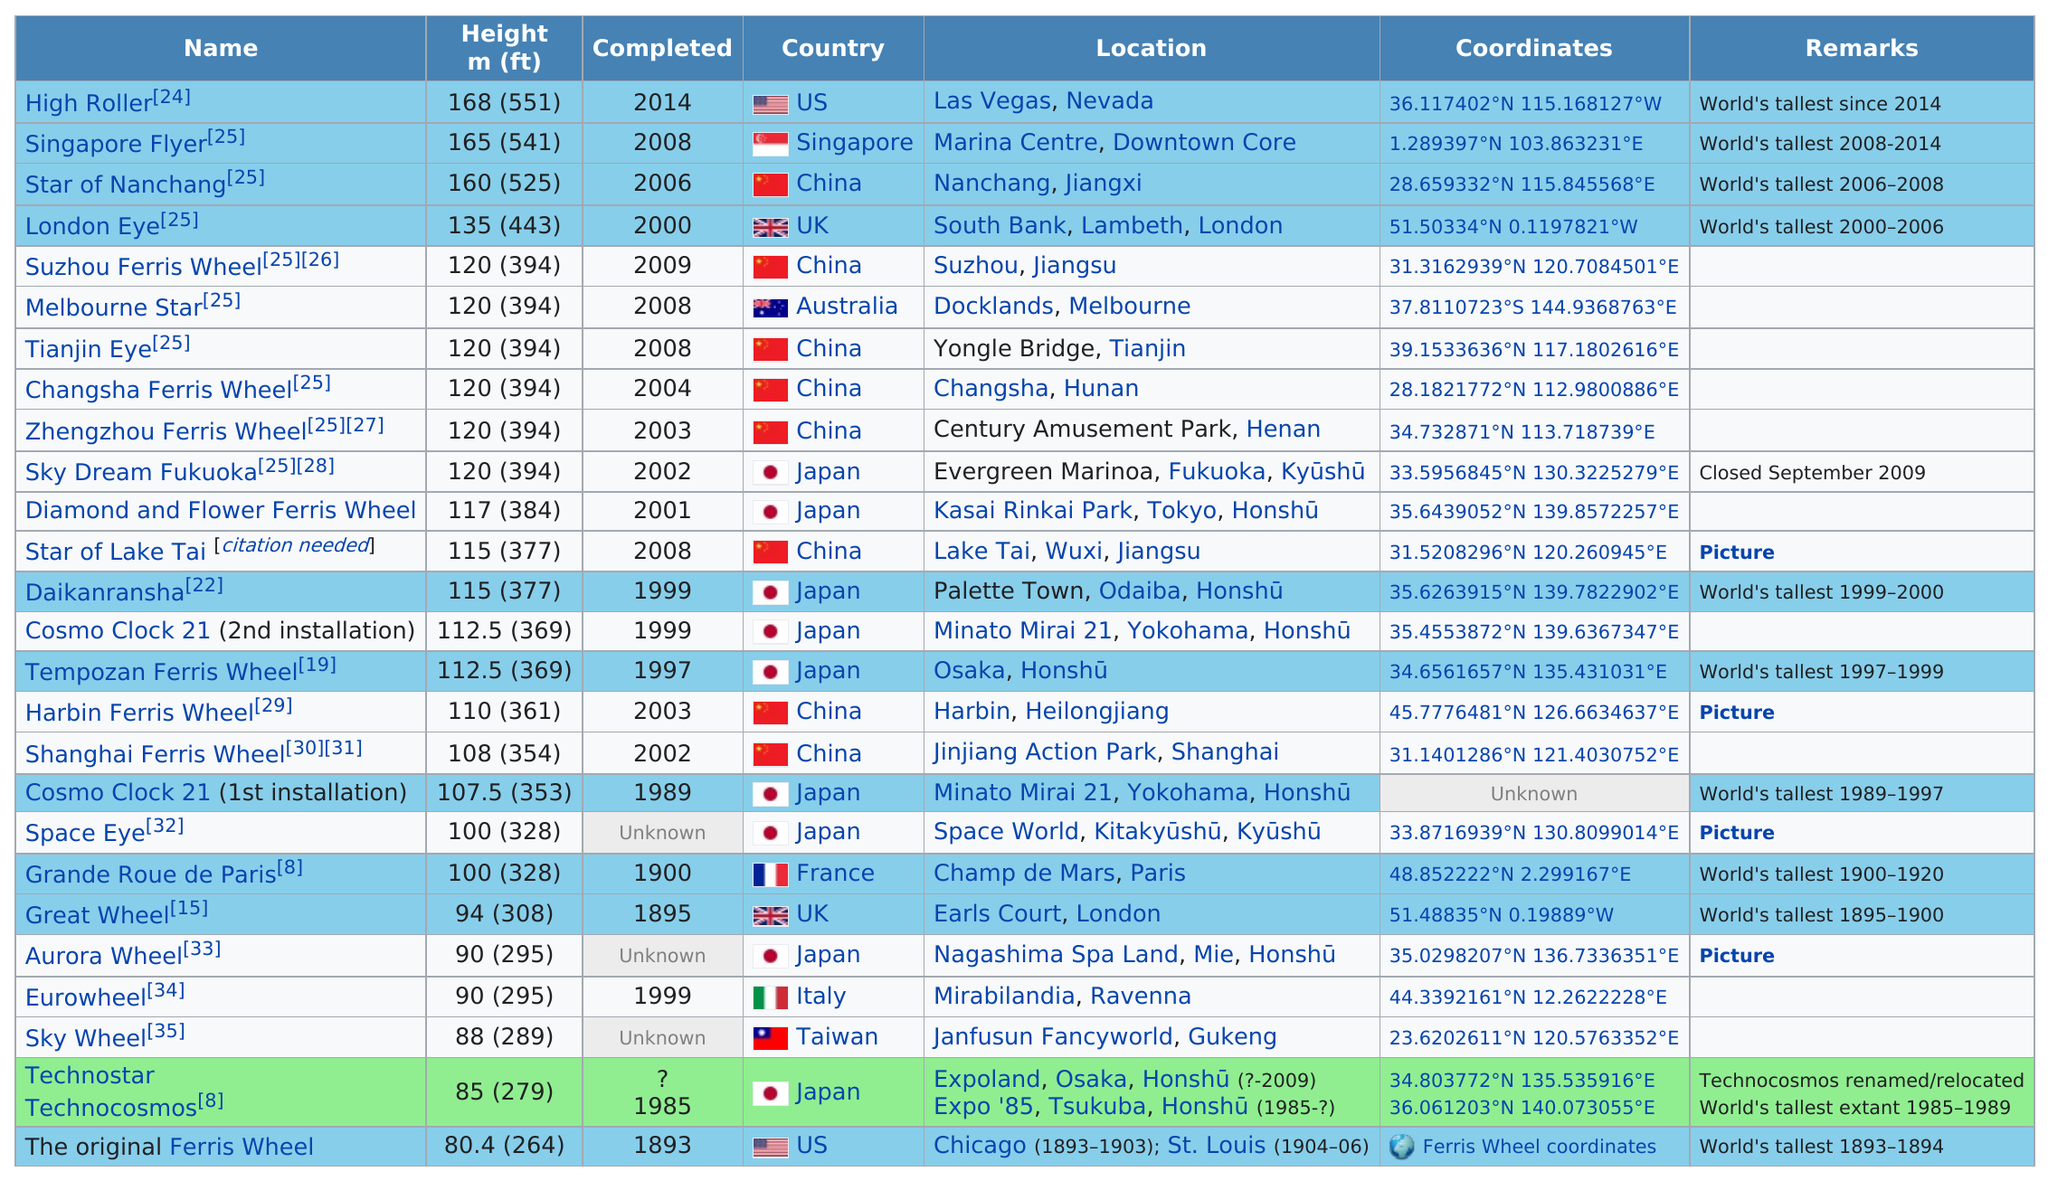Point out several critical features in this image. In 2008, China had the most roller coasters that were over 80 feet in height. The United States was home to the world's tallest roller coaster for a total of 2 years, from 1893 until 2014. The roller coaster known as the original tallest roller coaster was built in Chicago. The Singapore Flyer, a ferris wheel completed in 2008, stands at a height of 165 meters. Four Ferris wheels with a height of 120 and located in China have been identified. 